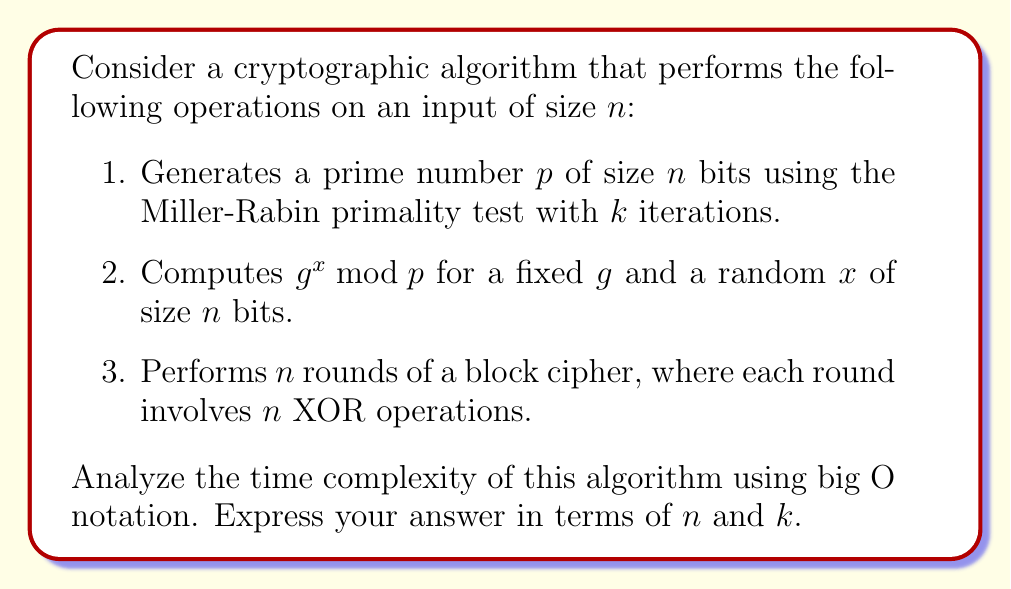Help me with this question. Let's analyze each step of the algorithm:

1. Prime number generation using Miller-Rabin test:
   - Each iteration of Miller-Rabin test takes $O(\log n)$ time using fast exponentiation.
   - We perform $k$ iterations.
   - The primality test is repeated until a prime is found. On average, this takes $O(\log n)$ attempts.
   Time complexity: $O(k \log^2 n)$

2. Modular exponentiation $g^x \bmod p$:
   - Using the square-and-multiply algorithm, this operation takes $O(\log n)$ time.
   Time complexity: $O(\log n)$

3. Block cipher rounds:
   - There are $n$ rounds.
   - Each round performs $n$ XOR operations.
   Time complexity: $O(n^2)$

To determine the overall time complexity, we sum up the complexities of each step:

$$O(k \log^2 n) + O(\log n) + O(n^2)$$

The dominant term in this expression is $O(n^2)$, as it grows faster than the other terms for large $n$. However, we need to keep $k$ in our notation as it's a separate parameter that could potentially be large.

Therefore, the overall time complexity is $O(k \log^2 n + n^2)$.
Answer: $O(k \log^2 n + n^2)$ 